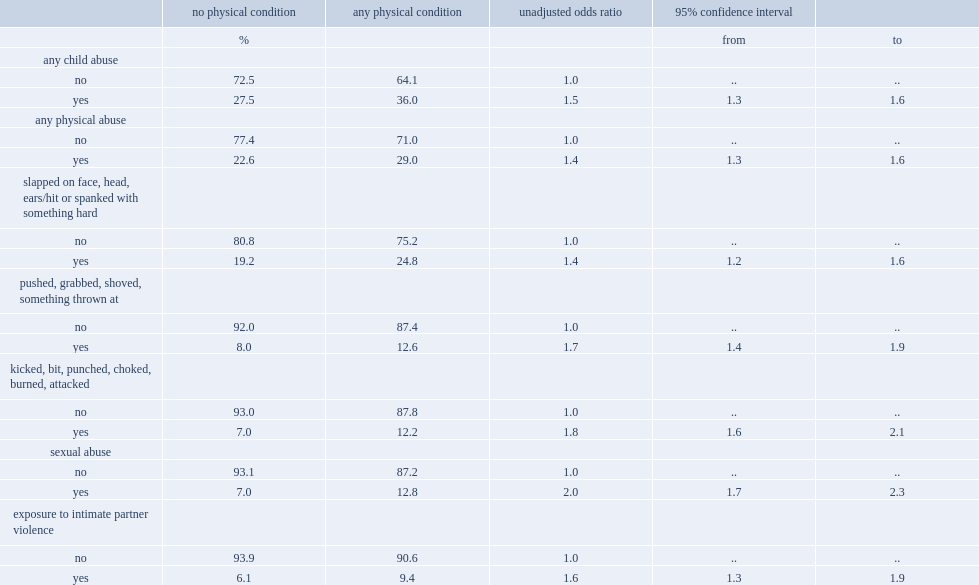What is the range of odd ratios relating abuse in childhood to physical conditions? 1.4 2. 